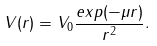Convert formula to latex. <formula><loc_0><loc_0><loc_500><loc_500>V ( r ) = V _ { 0 } \frac { e x p ( - \mu r ) } { r ^ { 2 } } .</formula> 